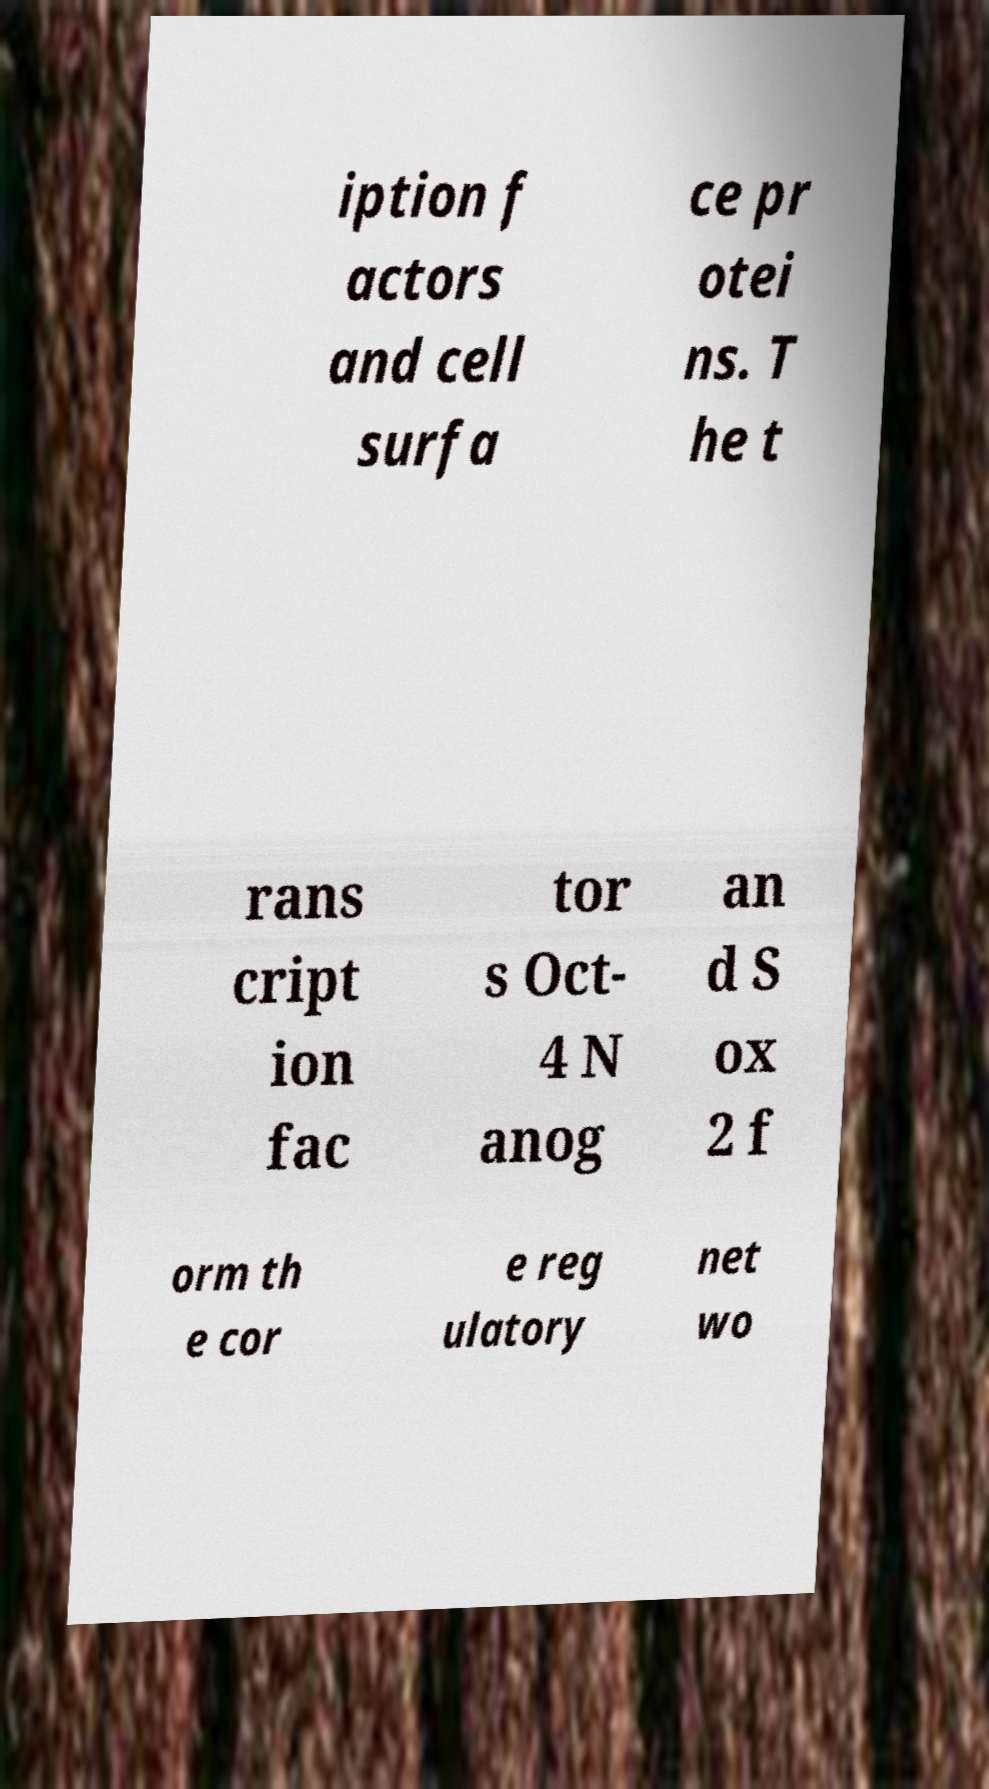Can you read and provide the text displayed in the image?This photo seems to have some interesting text. Can you extract and type it out for me? iption f actors and cell surfa ce pr otei ns. T he t rans cript ion fac tor s Oct- 4 N anog an d S ox 2 f orm th e cor e reg ulatory net wo 